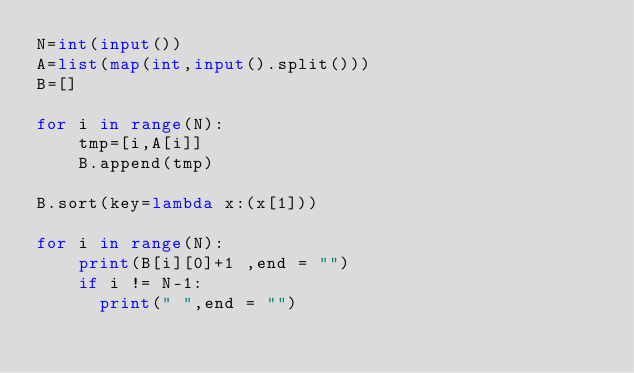<code> <loc_0><loc_0><loc_500><loc_500><_Python_>N=int(input())
A=list(map(int,input().split()))
B=[]

for i in range(N):
    tmp=[i,A[i]]
    B.append(tmp)

B.sort(key=lambda x:(x[1]))

for i in range(N):
    print(B[i][0]+1 ,end = "")
    if i != N-1:
      print(" ",end = "")</code> 